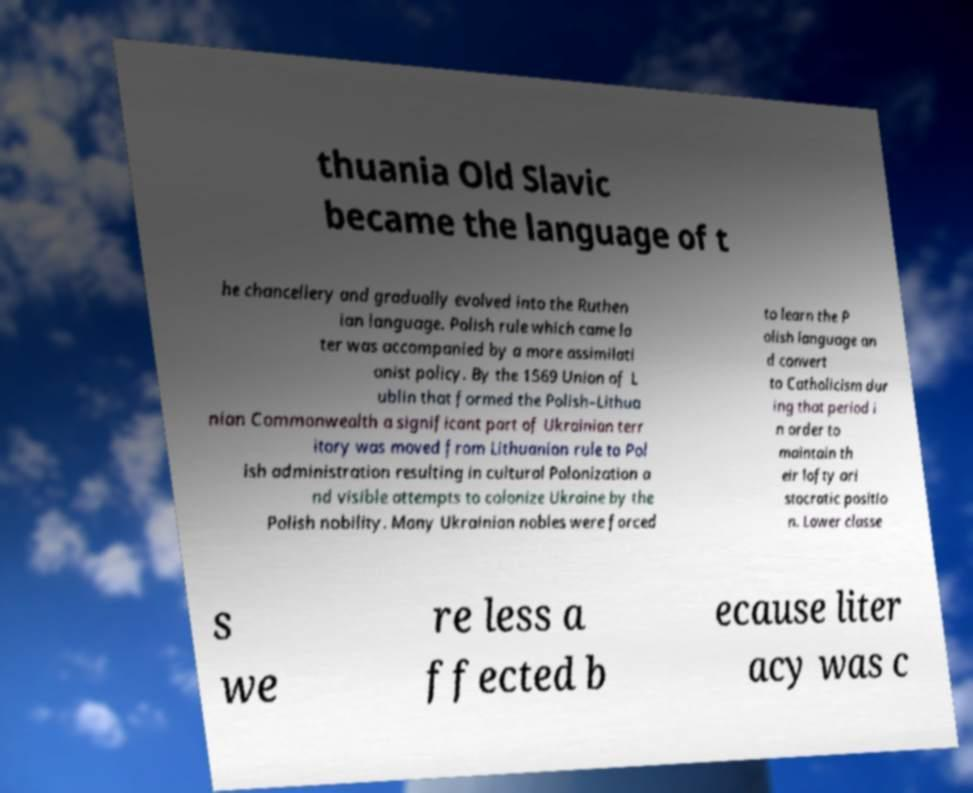Please read and relay the text visible in this image. What does it say? thuania Old Slavic became the language of t he chancellery and gradually evolved into the Ruthen ian language. Polish rule which came la ter was accompanied by a more assimilati onist policy. By the 1569 Union of L ublin that formed the Polish–Lithua nian Commonwealth a significant part of Ukrainian terr itory was moved from Lithuanian rule to Pol ish administration resulting in cultural Polonization a nd visible attempts to colonize Ukraine by the Polish nobility. Many Ukrainian nobles were forced to learn the P olish language an d convert to Catholicism dur ing that period i n order to maintain th eir lofty ari stocratic positio n. Lower classe s we re less a ffected b ecause liter acy was c 